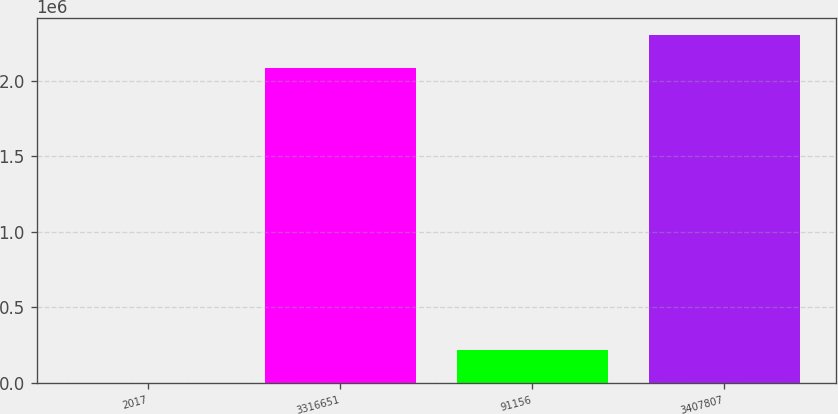Convert chart. <chart><loc_0><loc_0><loc_500><loc_500><bar_chart><fcel>2017<fcel>3316651<fcel>91156<fcel>3407807<nl><fcel>2016<fcel>2.08421e+06<fcel>219148<fcel>2.30134e+06<nl></chart> 